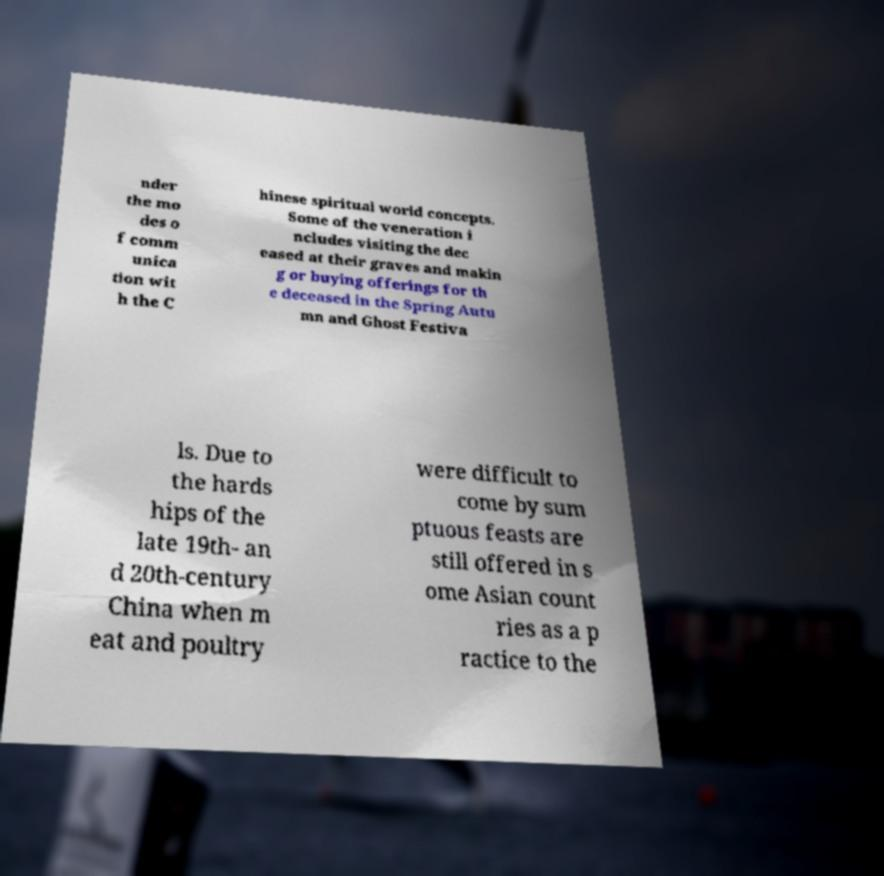I need the written content from this picture converted into text. Can you do that? nder the mo des o f comm unica tion wit h the C hinese spiritual world concepts. Some of the veneration i ncludes visiting the dec eased at their graves and makin g or buying offerings for th e deceased in the Spring Autu mn and Ghost Festiva ls. Due to the hards hips of the late 19th- an d 20th-century China when m eat and poultry were difficult to come by sum ptuous feasts are still offered in s ome Asian count ries as a p ractice to the 